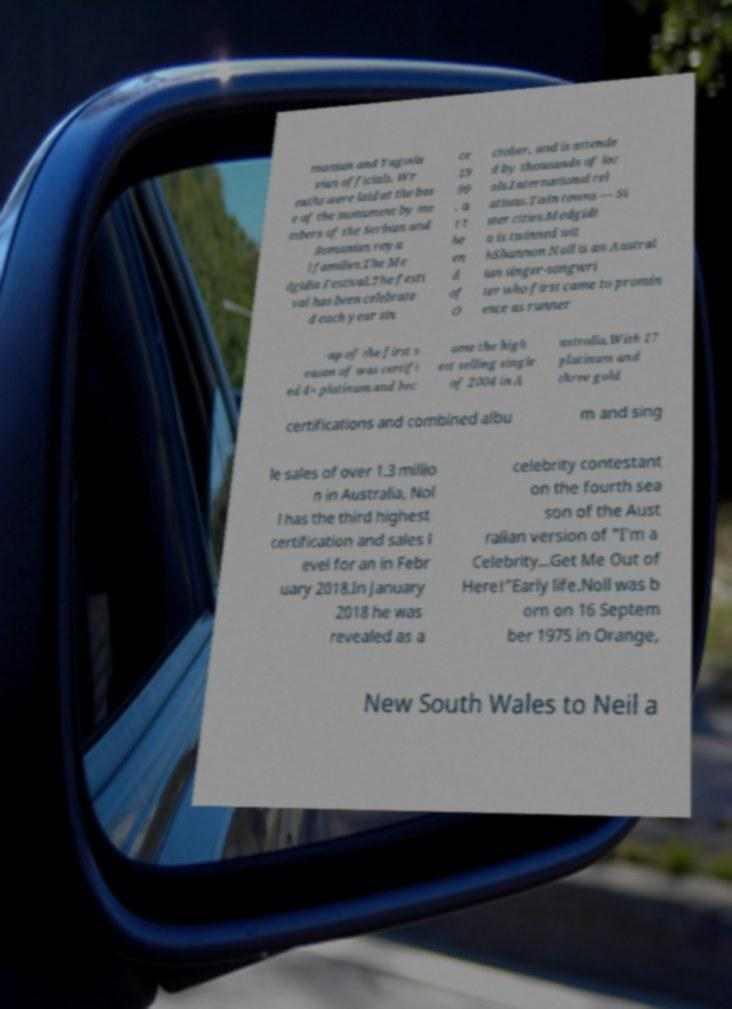Could you assist in decoding the text presented in this image and type it out clearly? manian and Yugosla vian officials. Wr eaths were laid at the bas e of the monument by me mbers of the Serbian and Romanian roya l families.The Me dgidia Festival.The festi val has been celebrate d each year sin ce 19 99 , a t t he en d of O ctober, and is attende d by thousands of loc als.International rel ations.Twin towns — Si ster cities.Medgidi a is twinned wit hShannon Noll is an Austral ian singer-songwri ter who first came to promin ence as runner -up of the first s eason of was certifi ed 4× platinum and bec ame the high est selling single of 2004 in A ustralia.With 17 platinum and three gold certifications and combined albu m and sing le sales of over 1.3 millio n in Australia, Nol l has the third highest certification and sales l evel for an in Febr uary 2018.In January 2018 he was revealed as a celebrity contestant on the fourth sea son of the Aust ralian version of "I'm a Celebrity...Get Me Out of Here!"Early life.Noll was b orn on 16 Septem ber 1975 in Orange, New South Wales to Neil a 